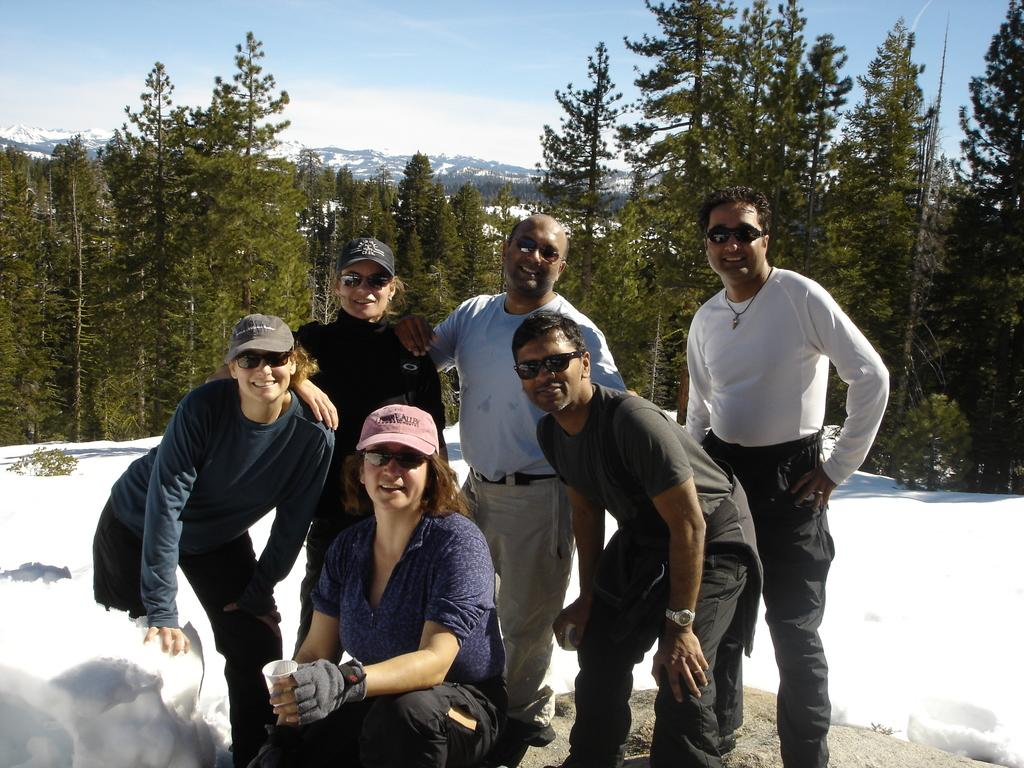How many people are in the image? There are people in the image, but the exact number is not specified. What are some people doing in the image? Some people are holding objects in the image. What is the condition of the ground in the image? The ground is covered with snow in the image. What type of vegetation can be seen in the image? There are trees in the image. What type of geographical feature is visible in the image? There are mountains with snow in the image. What part of the natural environment is visible in the image? The sky is visible in the image. Can you see a deer playing a pipe on someone's wrist in the image? No, there is no deer, pipe, or wrist activity present in the image. 